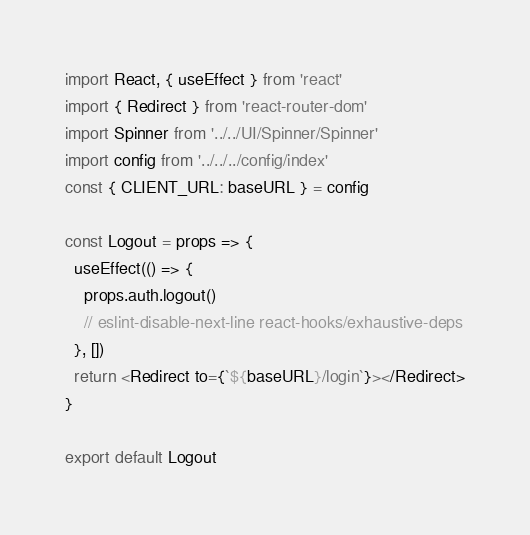<code> <loc_0><loc_0><loc_500><loc_500><_JavaScript_>import React, { useEffect } from 'react'
import { Redirect } from 'react-router-dom'
import Spinner from '../../UI/Spinner/Spinner'
import config from '../../../config/index'
const { CLIENT_URL: baseURL } = config

const Logout = props => {
  useEffect(() => {
    props.auth.logout()
    // eslint-disable-next-line react-hooks/exhaustive-deps
  }, [])
  return <Redirect to={`${baseURL}/login`}></Redirect>
}

export default Logout
</code> 